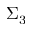Convert formula to latex. <formula><loc_0><loc_0><loc_500><loc_500>\Sigma _ { 3 }</formula> 